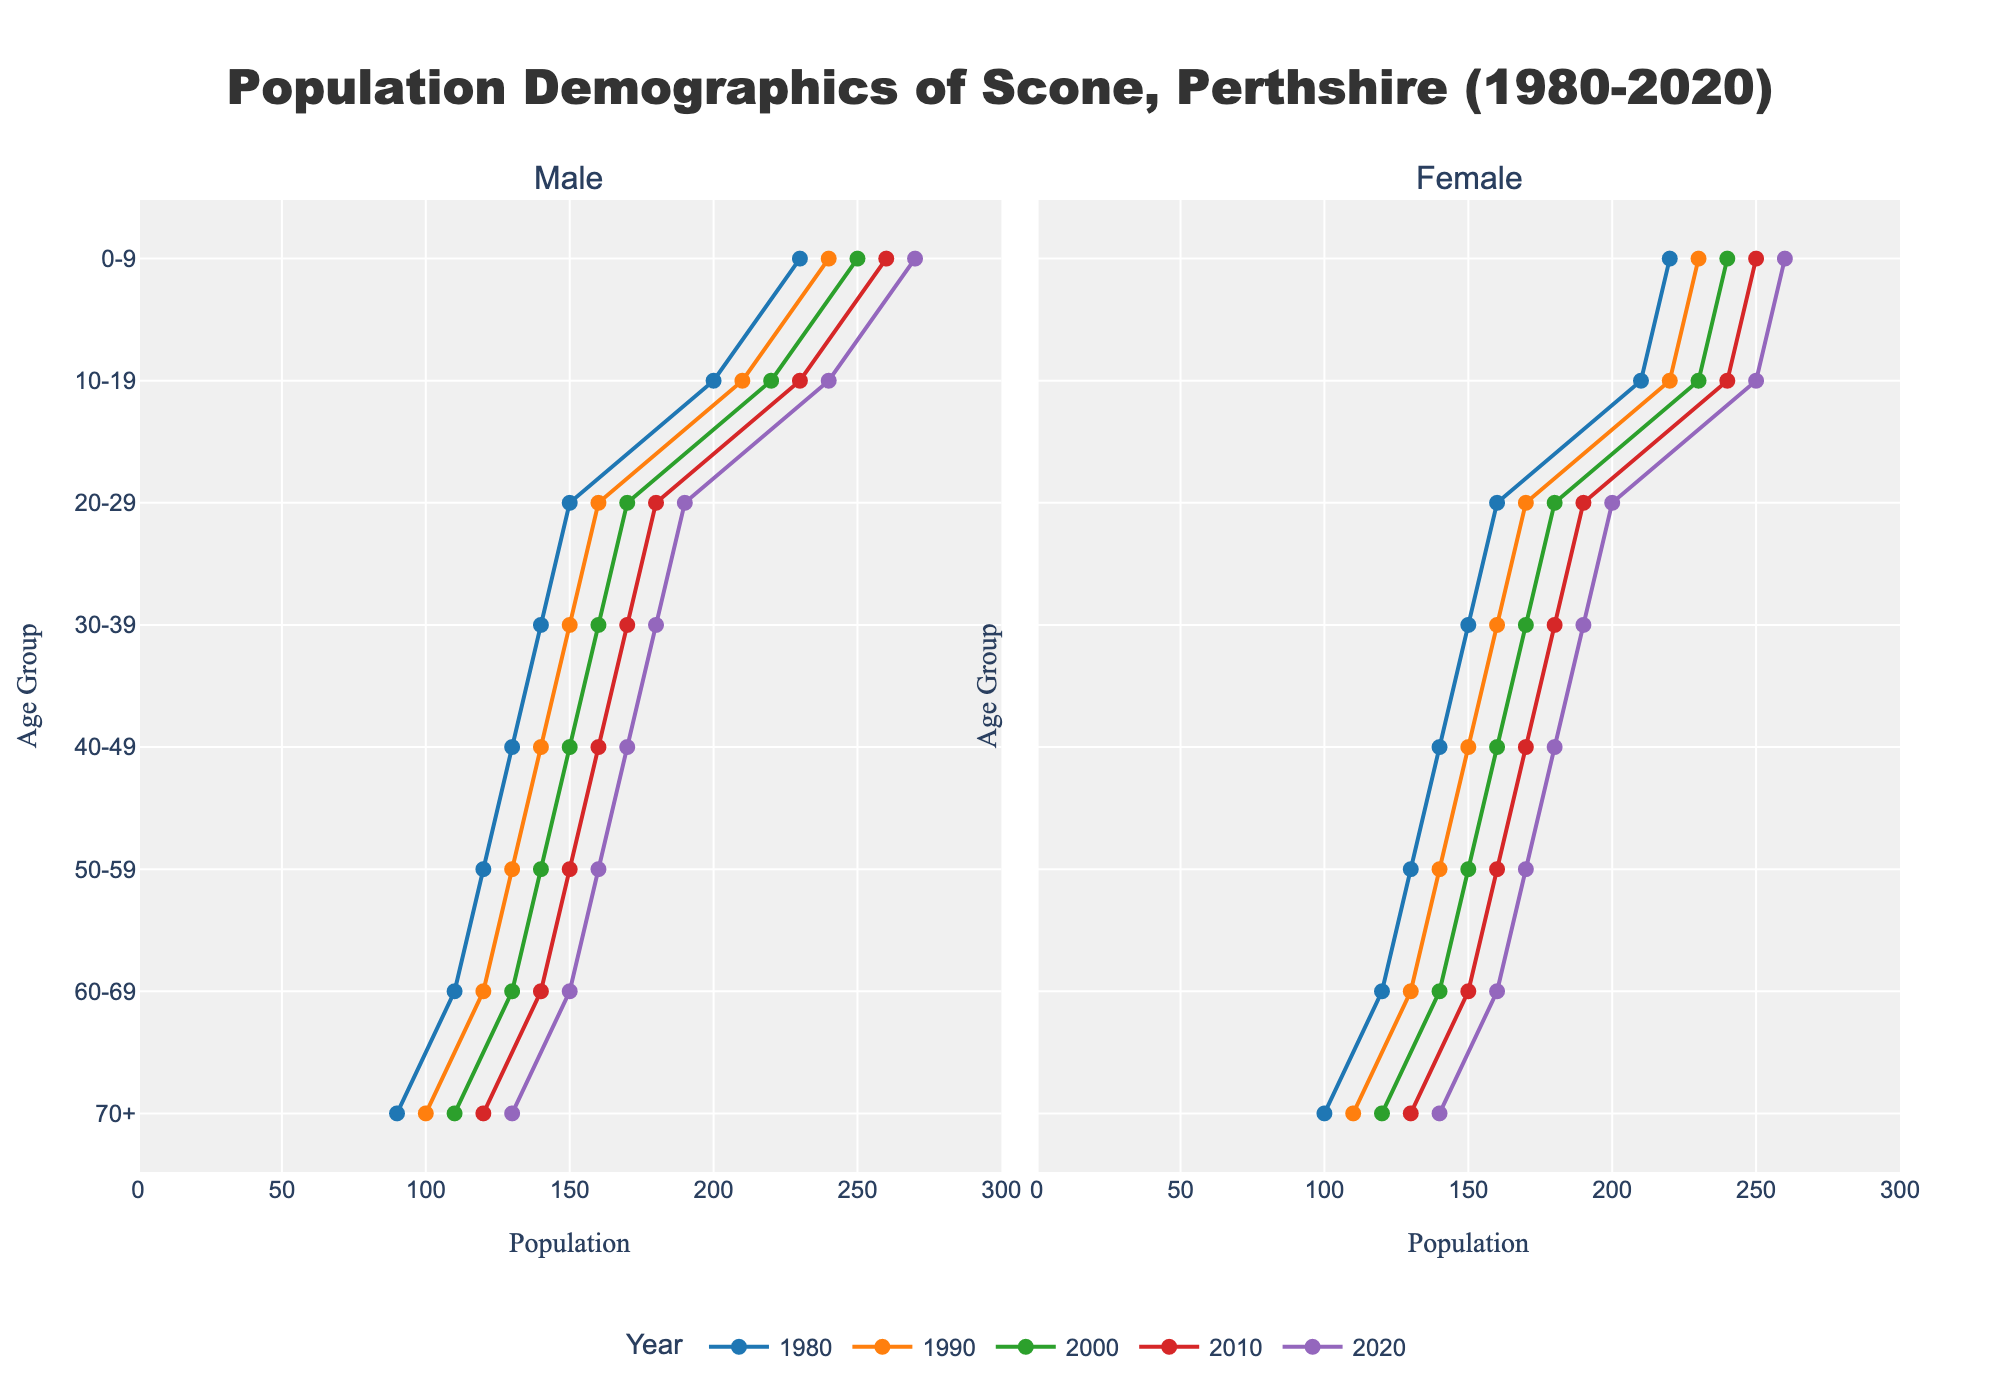What are the titles of the subplots? The titles of the subplots are shown at the top of each subplot in the figure. The left subplot title is 'Male' and the right one is 'Female'.
Answer: 'Male' and 'Female' How is the male population distributed for the age group 0-9 in 1980? Look at the left subplot under the age group 0-9. The male population for the age group 0-9 in 1980 is represented by one of the lines, and you can read off the value directly.
Answer: 230 What is the difference in the number of males between the age groups 0-9 and 10-19 in 2020? Find the male population for the age group 0-9 in 2020 (270) and the male population for the age group 10-19 in 2020 (240). Subtract the smaller number from the larger number: 270 - 240.
Answer: 30 How does the female population in the 30-39 age group change from 1980 to 2020? Observe the right subplot for the age group 30-39 and compare the female populations across the years 1980 to 2020: The female population in 1980 (150), 1990 (160), 2000 (170), 2010 (180), and 2020 (190). The population increases progressively.
Answer: Increases gradually Which year has the highest female population in the 70+ age group? Look at the right subplot and find the line that represents the female population in the 70+ age group across different years. The highest value is for 2020 (140).
Answer: 2020 In 1980, what is the total population for the age group 50-59? The total population for the age group 50-59 is the sum of the male and female populations for that age group in 1980. Male population is 120 and female population is 130. Add these numbers: 120 + 130.
Answer: 250 What is the average male population in the 20-29 age group over the years in the data? First, extract the male populations for the 20-29 age group for all the years: 1980 (150), 1990 (160), 2000 (170), 2010 (180), 2020 (190). Sum these values and divide by the number of years: (150 + 160 + 170 + 180 + 190) / 5.
Answer: 170 Which age group has the least difference between the male and female populations in 1990? Look at the male and female populations in each age group for 1990. Calculate the absolute differences, and find the minimum: 0-9 (10), 10-19 (10), 20-29 (10), 30-39 (10), 40-49 (10), 50-59 (10), 60-69 (10), 70+ (10). Every age group has the same difference of 10.
Answer: All age groups (each 10) What is the visual pattern of the color used for each year's line plots? Observe the colors used for the line plots for each year across both subplots. Different colors are consistently used for each year, rotating through a palette of 5 colors.
Answer: Consistent year-based colors 